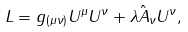<formula> <loc_0><loc_0><loc_500><loc_500>L = g _ { ( \mu \nu ) } U ^ { \mu } U ^ { \nu } + \lambda \hat { A } _ { \nu } U ^ { \nu } ,</formula> 